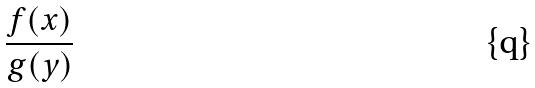Convert formula to latex. <formula><loc_0><loc_0><loc_500><loc_500>\frac { f ( x ) } { g ( y ) }</formula> 